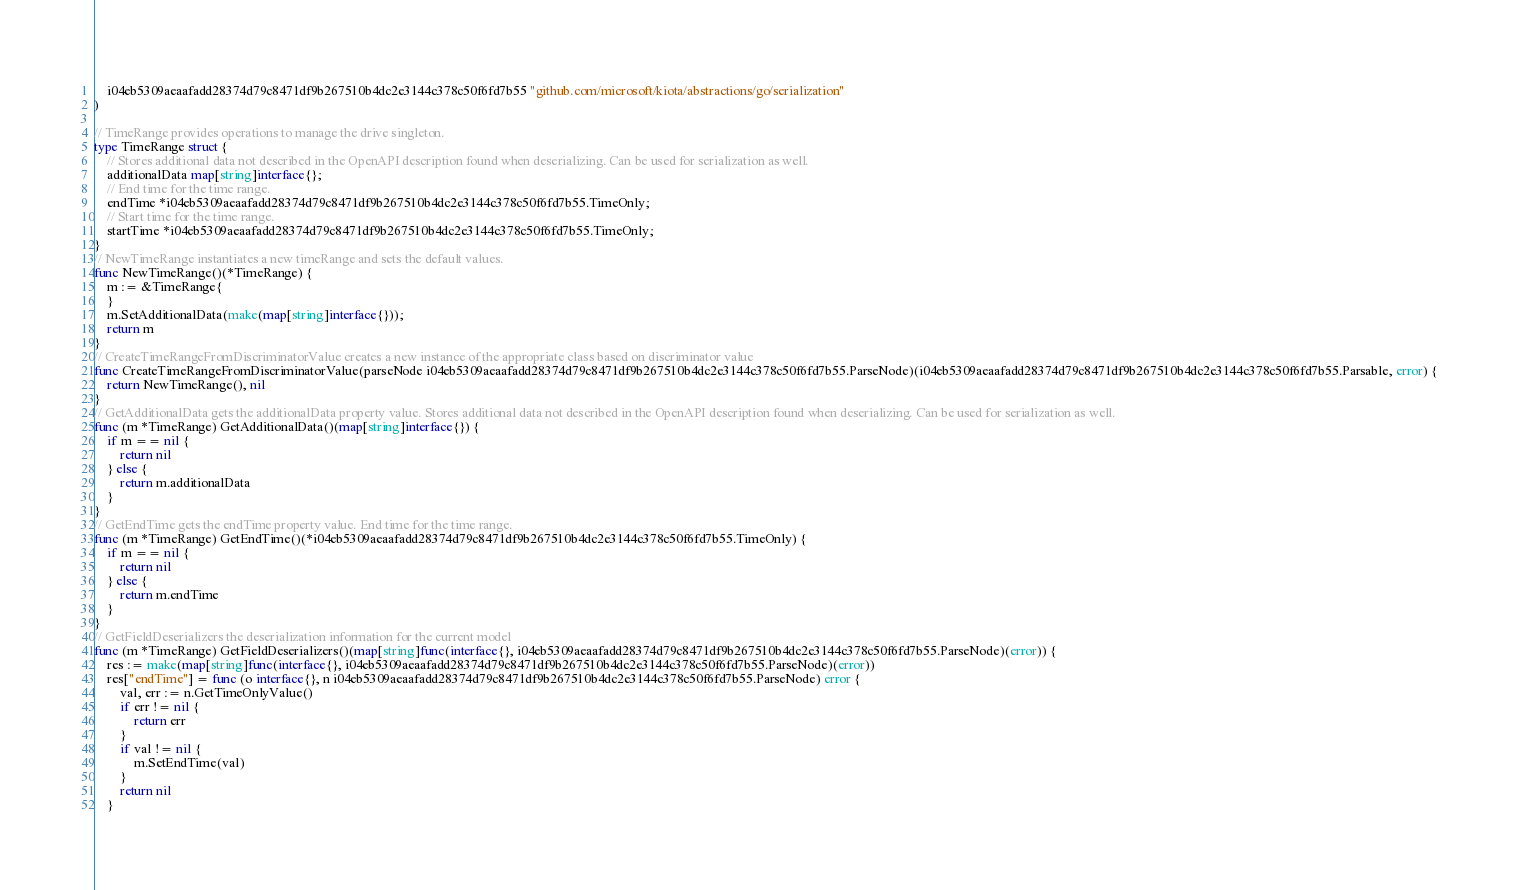<code> <loc_0><loc_0><loc_500><loc_500><_Go_>    i04eb5309aeaafadd28374d79c8471df9b267510b4dc2e3144c378c50f6fd7b55 "github.com/microsoft/kiota/abstractions/go/serialization"
)

// TimeRange provides operations to manage the drive singleton.
type TimeRange struct {
    // Stores additional data not described in the OpenAPI description found when deserializing. Can be used for serialization as well.
    additionalData map[string]interface{};
    // End time for the time range.
    endTime *i04eb5309aeaafadd28374d79c8471df9b267510b4dc2e3144c378c50f6fd7b55.TimeOnly;
    // Start time for the time range.
    startTime *i04eb5309aeaafadd28374d79c8471df9b267510b4dc2e3144c378c50f6fd7b55.TimeOnly;
}
// NewTimeRange instantiates a new timeRange and sets the default values.
func NewTimeRange()(*TimeRange) {
    m := &TimeRange{
    }
    m.SetAdditionalData(make(map[string]interface{}));
    return m
}
// CreateTimeRangeFromDiscriminatorValue creates a new instance of the appropriate class based on discriminator value
func CreateTimeRangeFromDiscriminatorValue(parseNode i04eb5309aeaafadd28374d79c8471df9b267510b4dc2e3144c378c50f6fd7b55.ParseNode)(i04eb5309aeaafadd28374d79c8471df9b267510b4dc2e3144c378c50f6fd7b55.Parsable, error) {
    return NewTimeRange(), nil
}
// GetAdditionalData gets the additionalData property value. Stores additional data not described in the OpenAPI description found when deserializing. Can be used for serialization as well.
func (m *TimeRange) GetAdditionalData()(map[string]interface{}) {
    if m == nil {
        return nil
    } else {
        return m.additionalData
    }
}
// GetEndTime gets the endTime property value. End time for the time range.
func (m *TimeRange) GetEndTime()(*i04eb5309aeaafadd28374d79c8471df9b267510b4dc2e3144c378c50f6fd7b55.TimeOnly) {
    if m == nil {
        return nil
    } else {
        return m.endTime
    }
}
// GetFieldDeserializers the deserialization information for the current model
func (m *TimeRange) GetFieldDeserializers()(map[string]func(interface{}, i04eb5309aeaafadd28374d79c8471df9b267510b4dc2e3144c378c50f6fd7b55.ParseNode)(error)) {
    res := make(map[string]func(interface{}, i04eb5309aeaafadd28374d79c8471df9b267510b4dc2e3144c378c50f6fd7b55.ParseNode)(error))
    res["endTime"] = func (o interface{}, n i04eb5309aeaafadd28374d79c8471df9b267510b4dc2e3144c378c50f6fd7b55.ParseNode) error {
        val, err := n.GetTimeOnlyValue()
        if err != nil {
            return err
        }
        if val != nil {
            m.SetEndTime(val)
        }
        return nil
    }</code> 